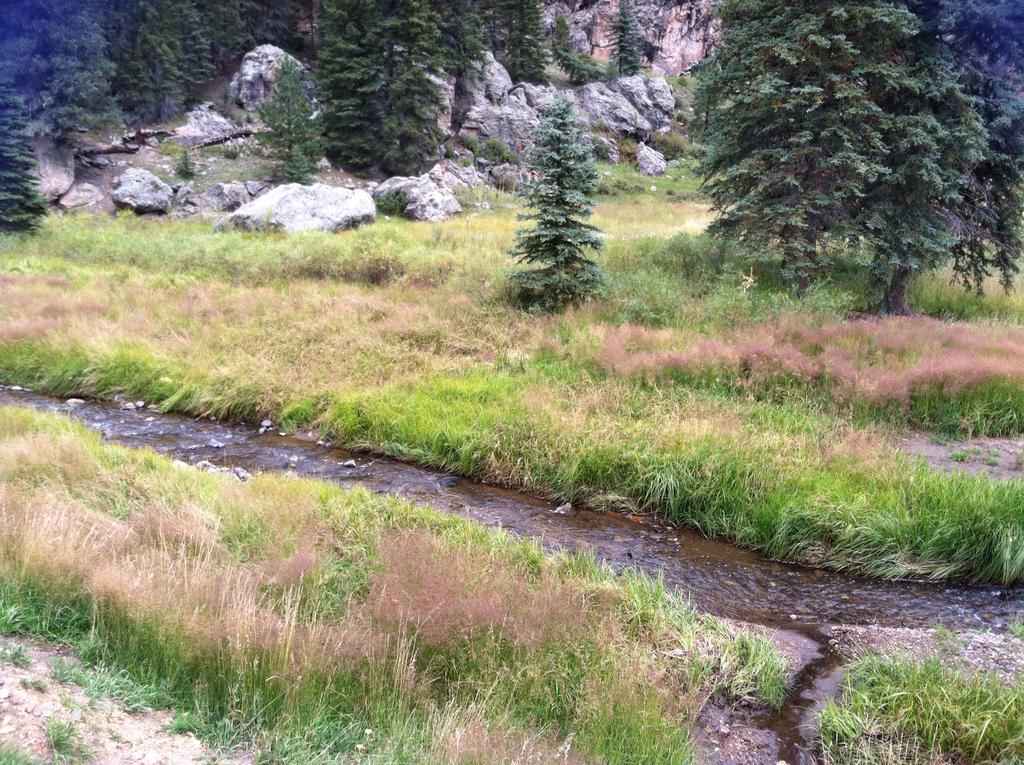In one or two sentences, can you explain what this image depicts? In this image there is a grass field and a small water flow at the middle beside that there are so many trees and rocks. 